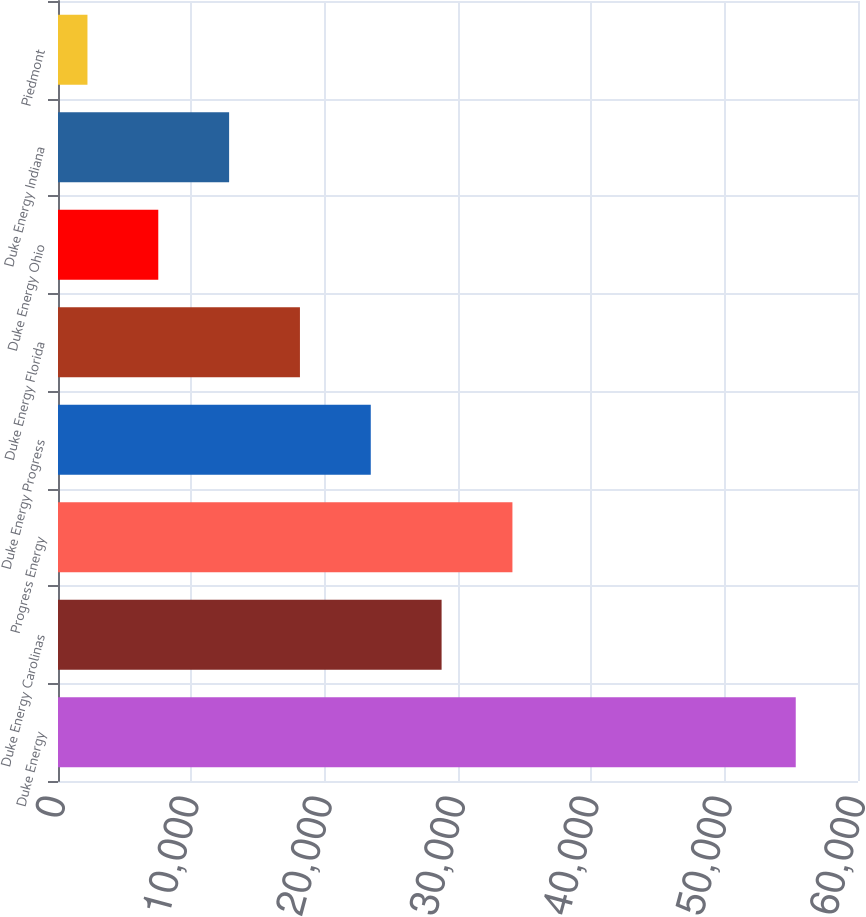<chart> <loc_0><loc_0><loc_500><loc_500><bar_chart><fcel>Duke Energy<fcel>Duke Energy Carolinas<fcel>Progress Energy<fcel>Duke Energy Progress<fcel>Duke Energy Florida<fcel>Duke Energy Ohio<fcel>Duke Energy Indiana<fcel>Piedmont<nl><fcel>55331<fcel>28770<fcel>34082.2<fcel>23457.8<fcel>18145.6<fcel>7521.2<fcel>12833.4<fcel>2209<nl></chart> 